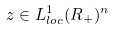<formula> <loc_0><loc_0><loc_500><loc_500>z \in L _ { l o c } ^ { 1 } ( R _ { + } ) ^ { n }</formula> 